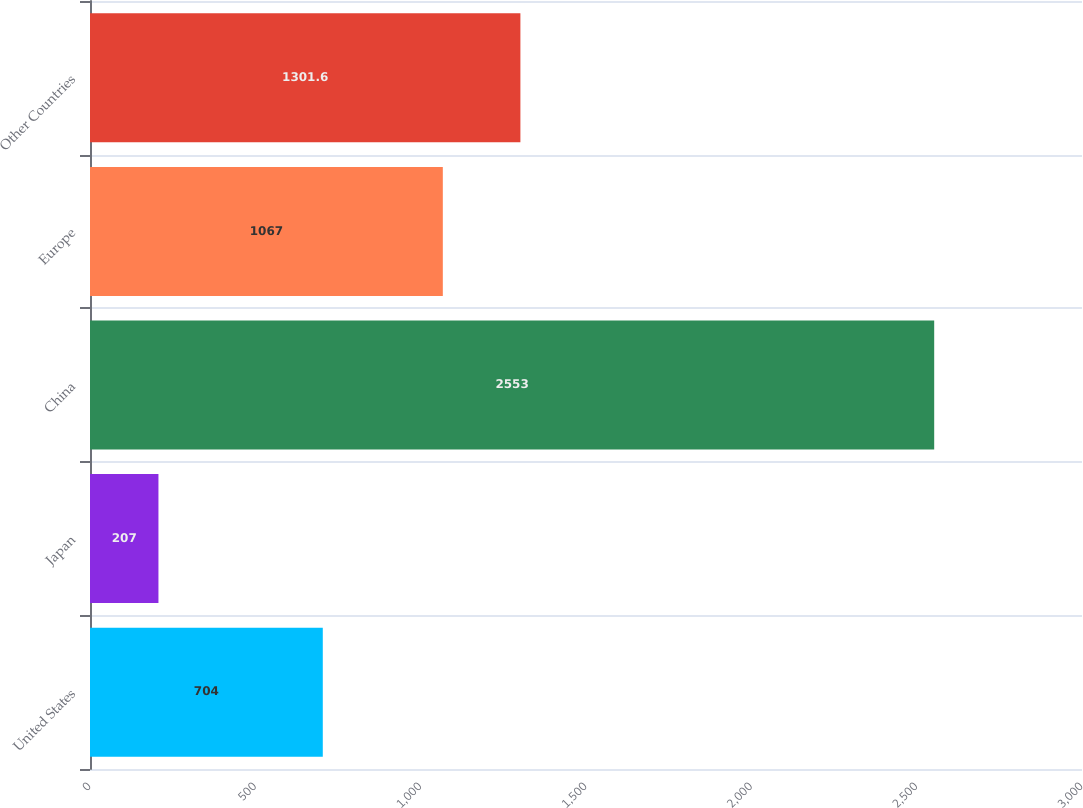Convert chart. <chart><loc_0><loc_0><loc_500><loc_500><bar_chart><fcel>United States<fcel>Japan<fcel>China<fcel>Europe<fcel>Other Countries<nl><fcel>704<fcel>207<fcel>2553<fcel>1067<fcel>1301.6<nl></chart> 